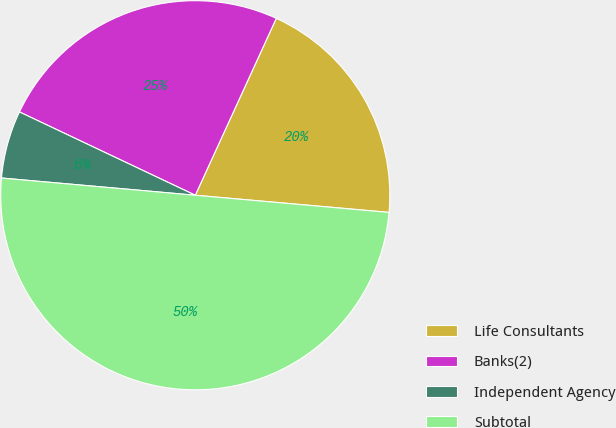Convert chart to OTSL. <chart><loc_0><loc_0><loc_500><loc_500><pie_chart><fcel>Life Consultants<fcel>Banks(2)<fcel>Independent Agency<fcel>Subtotal<nl><fcel>19.57%<fcel>24.79%<fcel>5.63%<fcel>50.0%<nl></chart> 